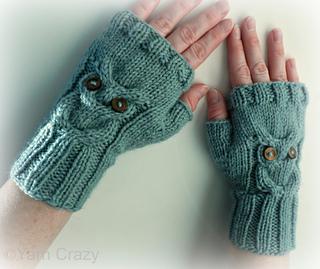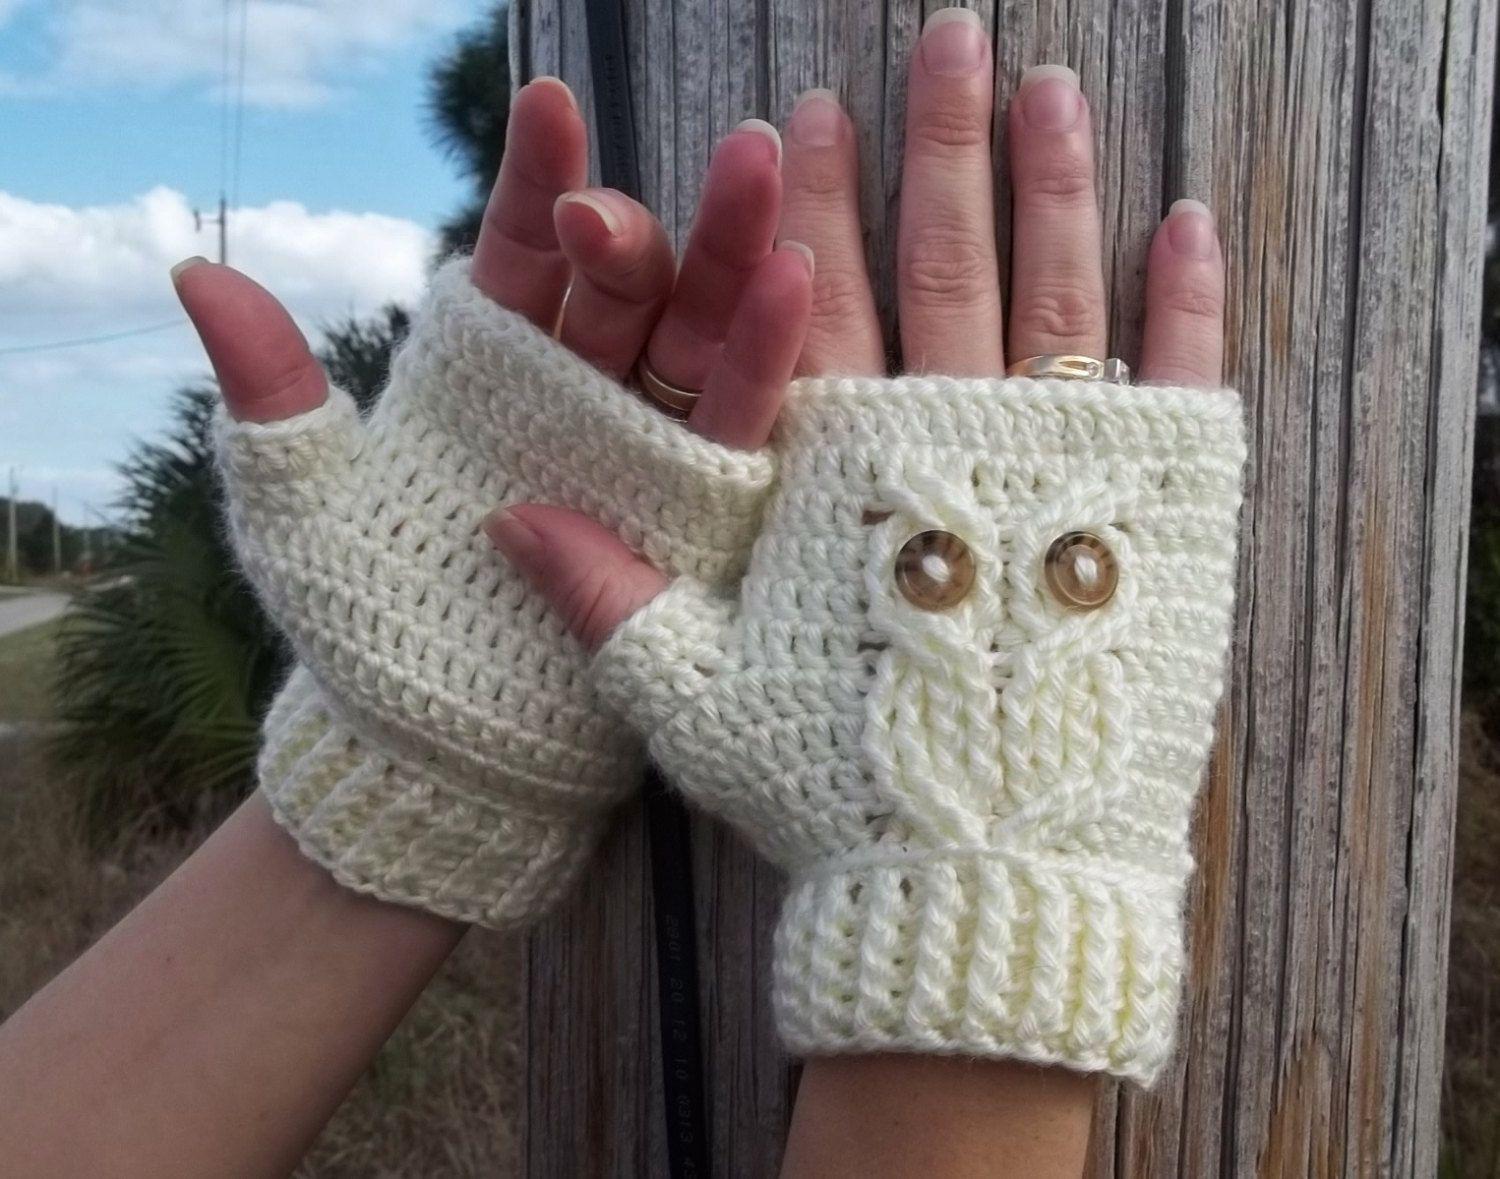The first image is the image on the left, the second image is the image on the right. Considering the images on both sides, is "Four hands have gloves on them." valid? Answer yes or no. Yes. 